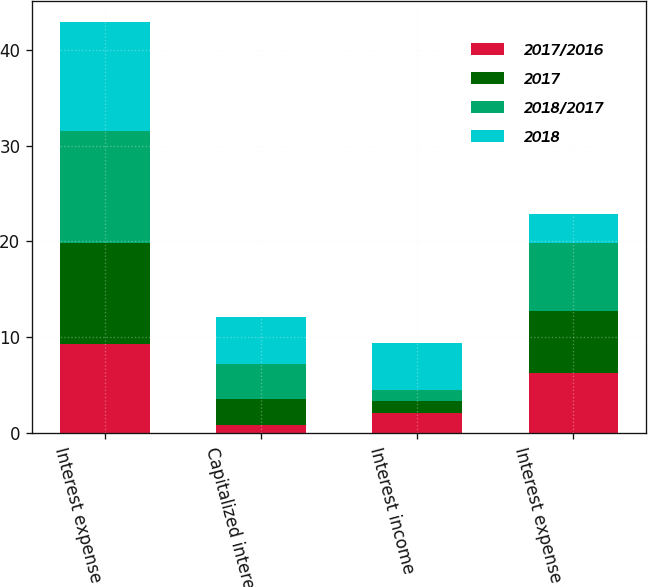Convert chart. <chart><loc_0><loc_0><loc_500><loc_500><stacked_bar_chart><ecel><fcel>Interest expense<fcel>Capitalized interest<fcel>Interest income<fcel>Interest expense net<nl><fcel>2017/2016<fcel>9.3<fcel>0.9<fcel>2.1<fcel>6.3<nl><fcel>2017<fcel>10.5<fcel>2.7<fcel>1.3<fcel>6.5<nl><fcel>2018/2017<fcel>11.7<fcel>3.6<fcel>1.1<fcel>7<nl><fcel>2018<fcel>11.4<fcel>4.95<fcel>4.95<fcel>3.1<nl></chart> 